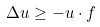Convert formula to latex. <formula><loc_0><loc_0><loc_500><loc_500>\Delta u \geq - u \cdot f</formula> 